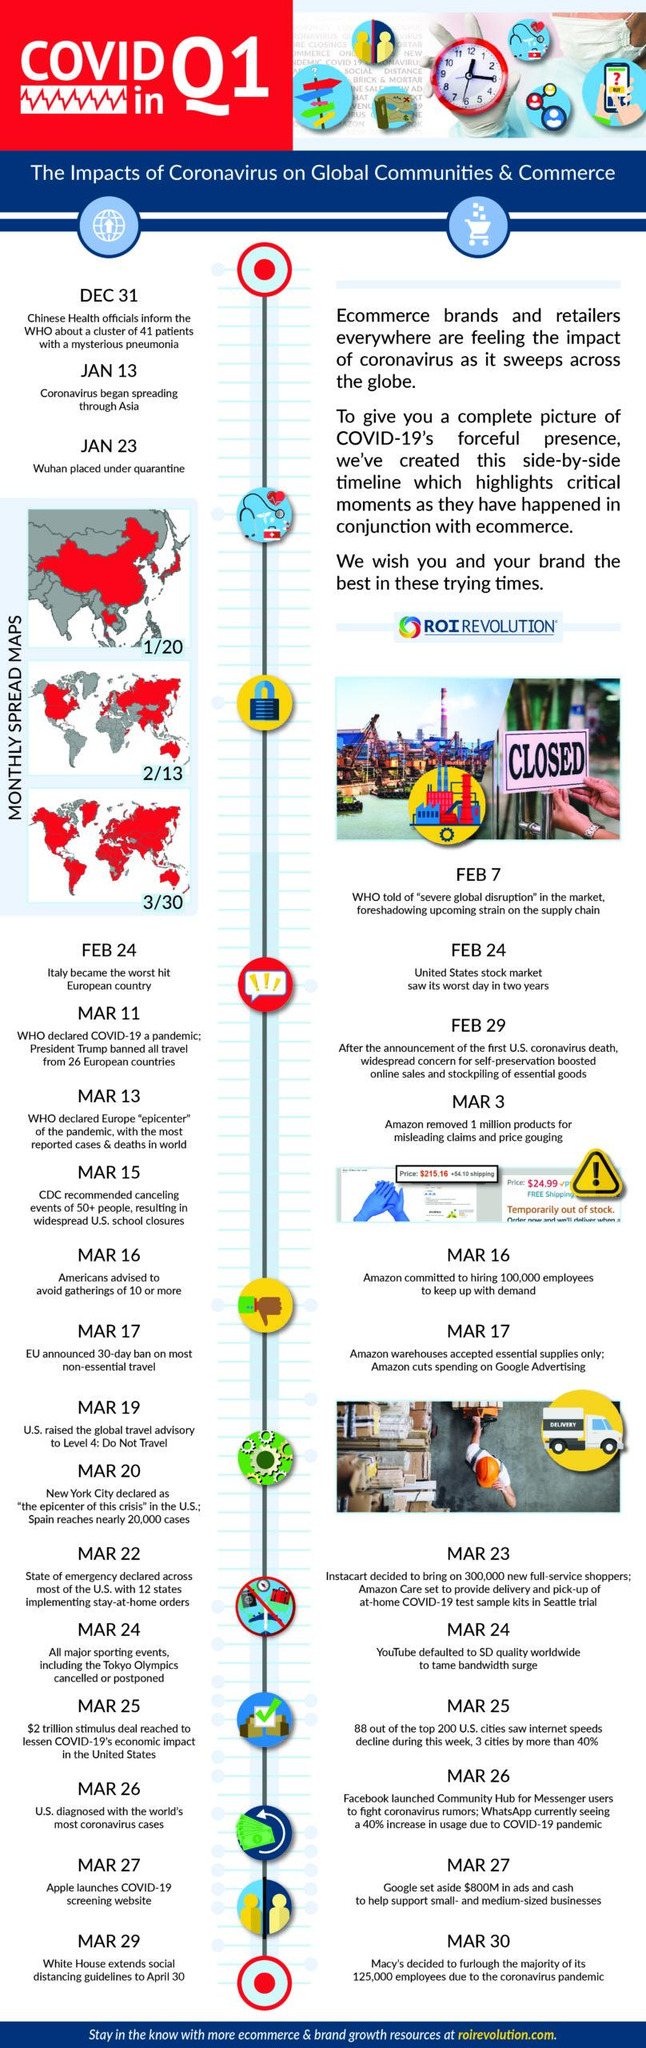List a handful of essential elements in this visual. Apple launched its COVID-19 screening website on March 27, 2022. The European Union has announced a ban on most non-essential travel for 30 days, effective from March 17. Amazon removed one million products for misleading claims and price gouging on March 3. 